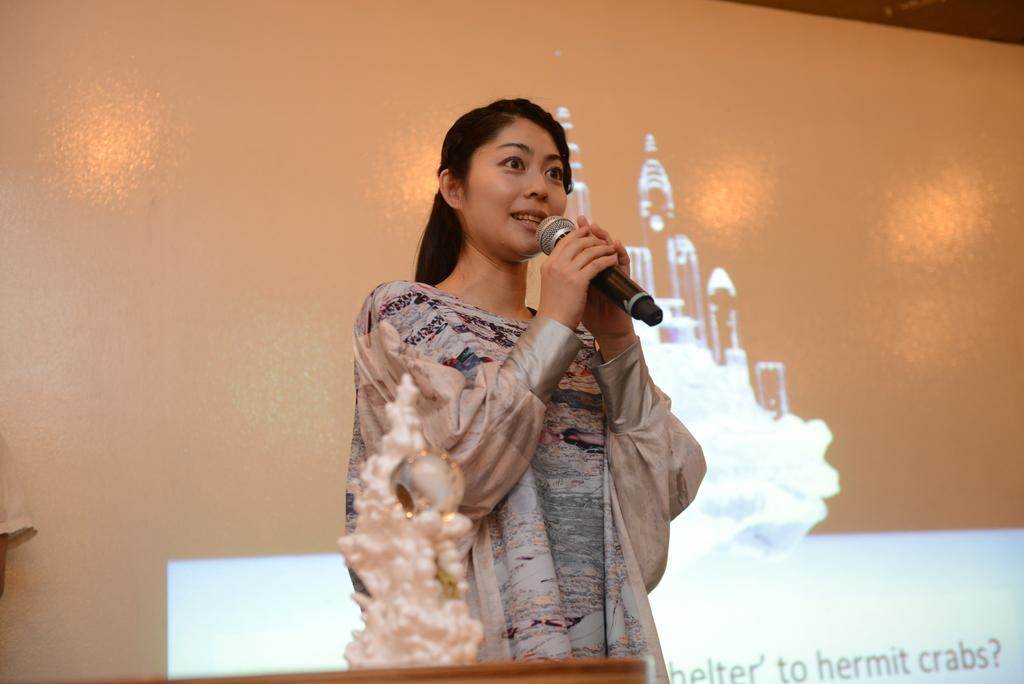Who is the main subject in the image? There is a woman in the image. What is the woman doing in the image? The woman is standing and talking. What is the woman holding in her hand? The woman is holding a microphone in her hand. What can be seen in the background of the image? There is a wall and a board in the background of the image. Where is the scarecrow located in the image? There is no scarecrow present in the image. What type of dinosaurs can be seen in the background of the image? There are no dinosaurs present in the image; only a wall and a board can be seen in the background. 